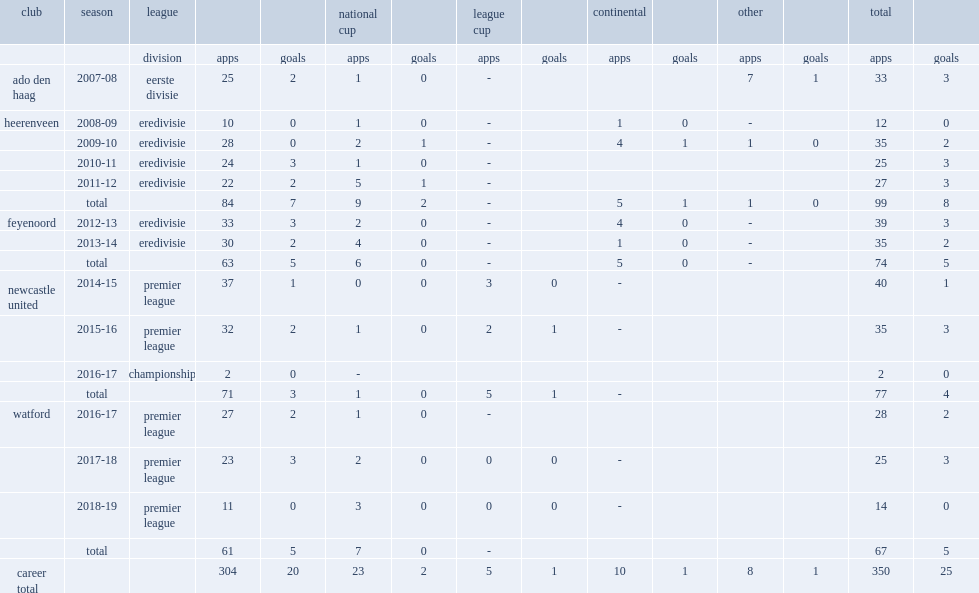Janmaat started his career in 2007-08, which league did he join with ado den haag in? Eerste divisie. Can you parse all the data within this table? {'header': ['club', 'season', 'league', '', '', 'national cup', '', 'league cup', '', 'continental', '', 'other', '', 'total', ''], 'rows': [['', '', 'division', 'apps', 'goals', 'apps', 'goals', 'apps', 'goals', 'apps', 'goals', 'apps', 'goals', 'apps', 'goals'], ['ado den haag', '2007-08', 'eerste divisie', '25', '2', '1', '0', '-', '', '', '', '7', '1', '33', '3'], ['heerenveen', '2008-09', 'eredivisie', '10', '0', '1', '0', '-', '', '1', '0', '-', '', '12', '0'], ['', '2009-10', 'eredivisie', '28', '0', '2', '1', '-', '', '4', '1', '1', '0', '35', '2'], ['', '2010-11', 'eredivisie', '24', '3', '1', '0', '-', '', '', '', '', '', '25', '3'], ['', '2011-12', 'eredivisie', '22', '2', '5', '1', '-', '', '', '', '', '', '27', '3'], ['', 'total', '', '84', '7', '9', '2', '-', '', '5', '1', '1', '0', '99', '8'], ['feyenoord', '2012-13', 'eredivisie', '33', '3', '2', '0', '-', '', '4', '0', '-', '', '39', '3'], ['', '2013-14', 'eredivisie', '30', '2', '4', '0', '-', '', '1', '0', '-', '', '35', '2'], ['', 'total', '', '63', '5', '6', '0', '-', '', '5', '0', '-', '', '74', '5'], ['newcastle united', '2014-15', 'premier league', '37', '1', '0', '0', '3', '0', '-', '', '', '', '40', '1'], ['', '2015-16', 'premier league', '32', '2', '1', '0', '2', '1', '-', '', '', '', '35', '3'], ['', '2016-17', 'championship', '2', '0', '-', '', '', '', '', '', '', '', '2', '0'], ['', 'total', '', '71', '3', '1', '0', '5', '1', '-', '', '', '', '77', '4'], ['watford', '2016-17', 'premier league', '27', '2', '1', '0', '-', '', '', '', '', '', '28', '2'], ['', '2017-18', 'premier league', '23', '3', '2', '0', '0', '0', '-', '', '', '', '25', '3'], ['', '2018-19', 'premier league', '11', '0', '3', '0', '0', '0', '-', '', '', '', '14', '0'], ['', 'total', '', '61', '5', '7', '0', '-', '', '', '', '', '', '67', '5'], ['career total', '', '', '304', '20', '23', '2', '5', '1', '10', '1', '8', '1', '350', '25']]} 